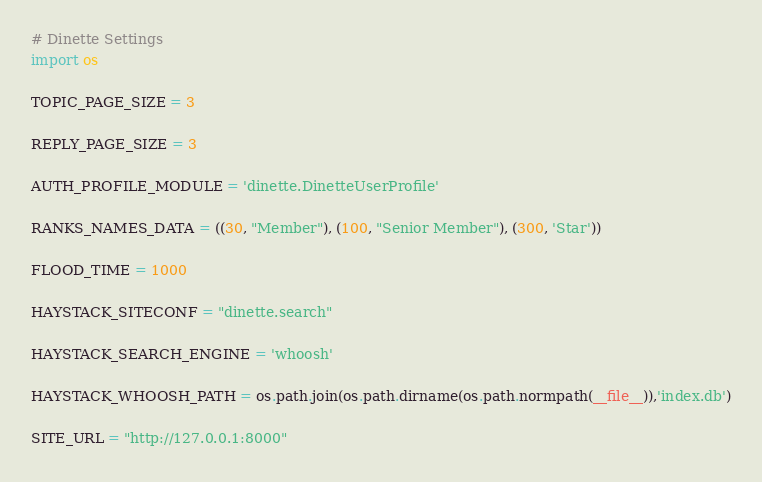<code> <loc_0><loc_0><loc_500><loc_500><_Python_># Dinette Settings
import os

TOPIC_PAGE_SIZE = 3

REPLY_PAGE_SIZE = 3

AUTH_PROFILE_MODULE = 'dinette.DinetteUserProfile'

RANKS_NAMES_DATA = ((30, "Member"), (100, "Senior Member"), (300, 'Star'))

FLOOD_TIME = 1000

HAYSTACK_SITECONF = "dinette.search"

HAYSTACK_SEARCH_ENGINE = 'whoosh'

HAYSTACK_WHOOSH_PATH = os.path.join(os.path.dirname(os.path.normpath(__file__)),'index.db')

SITE_URL = "http://127.0.0.1:8000"
</code> 